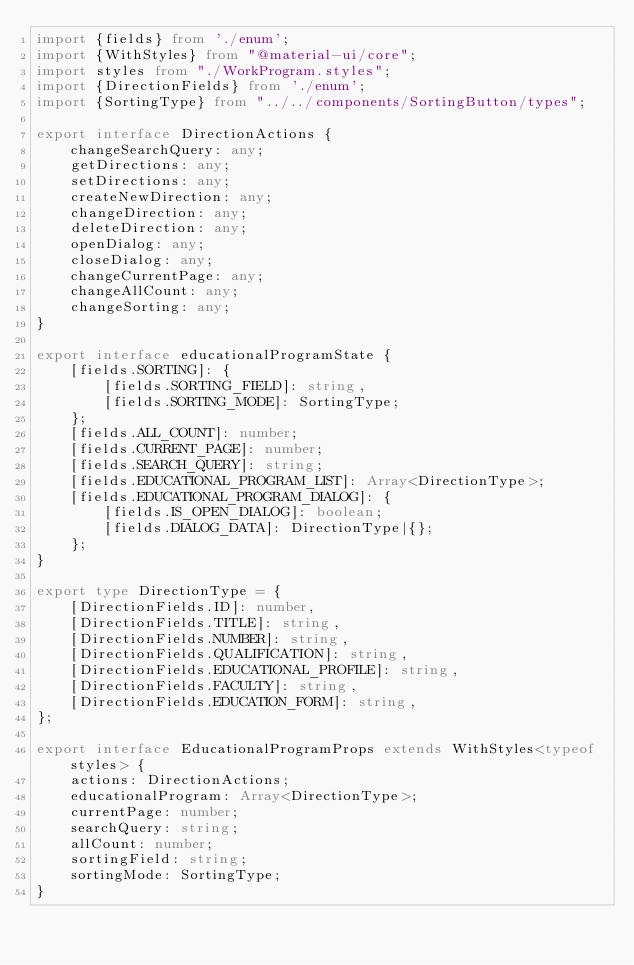<code> <loc_0><loc_0><loc_500><loc_500><_TypeScript_>import {fields} from './enum';
import {WithStyles} from "@material-ui/core";
import styles from "./WorkProgram.styles";
import {DirectionFields} from './enum';
import {SortingType} from "../../components/SortingButton/types";

export interface DirectionActions {
    changeSearchQuery: any;
    getDirections: any;
    setDirections: any;
    createNewDirection: any;
    changeDirection: any;
    deleteDirection: any;
    openDialog: any;
    closeDialog: any;
    changeCurrentPage: any;
    changeAllCount: any;
    changeSorting: any;
}

export interface educationalProgramState {
    [fields.SORTING]: {
        [fields.SORTING_FIELD]: string,
        [fields.SORTING_MODE]: SortingType;
    };
    [fields.ALL_COUNT]: number;
    [fields.CURRENT_PAGE]: number;
    [fields.SEARCH_QUERY]: string;
    [fields.EDUCATIONAL_PROGRAM_LIST]: Array<DirectionType>;
    [fields.EDUCATIONAL_PROGRAM_DIALOG]: {
        [fields.IS_OPEN_DIALOG]: boolean;
        [fields.DIALOG_DATA]: DirectionType|{};
    };
}

export type DirectionType = {
    [DirectionFields.ID]: number,
    [DirectionFields.TITLE]: string,
    [DirectionFields.NUMBER]: string,
    [DirectionFields.QUALIFICATION]: string,
    [DirectionFields.EDUCATIONAL_PROFILE]: string,
    [DirectionFields.FACULTY]: string,
    [DirectionFields.EDUCATION_FORM]: string,
};

export interface EducationalProgramProps extends WithStyles<typeof styles> {
    actions: DirectionActions;
    educationalProgram: Array<DirectionType>;
    currentPage: number;
    searchQuery: string;
    allCount: number;
    sortingField: string;
    sortingMode: SortingType;
}</code> 